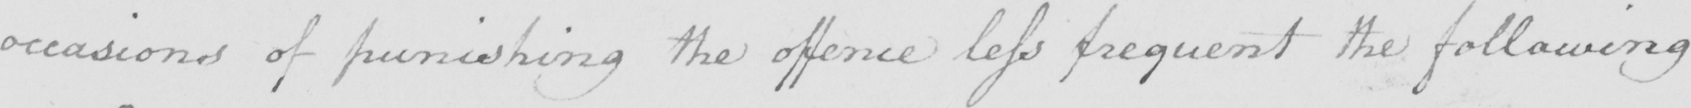What is written in this line of handwriting? occasions of punishing the offence less frequent the following 